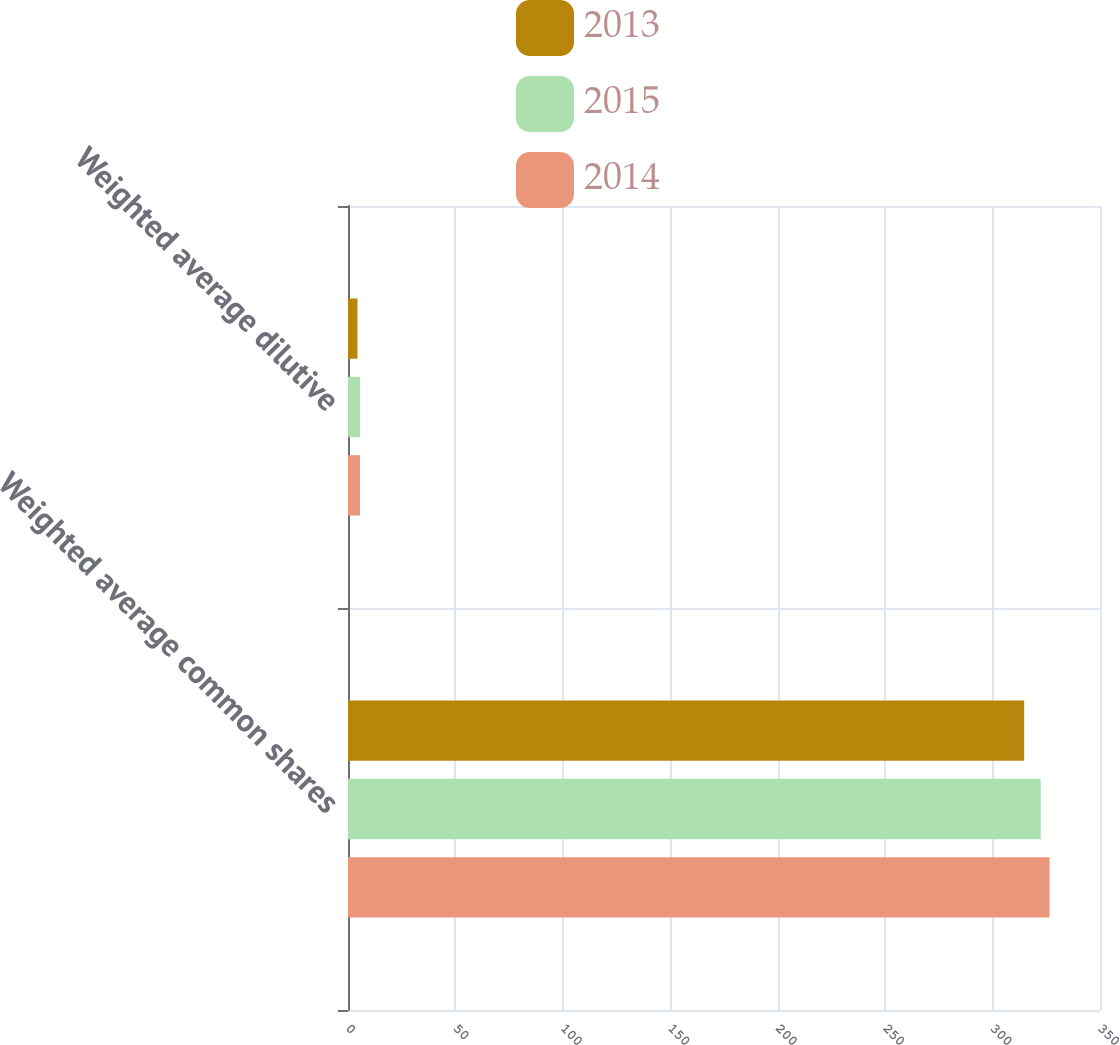Convert chart to OTSL. <chart><loc_0><loc_0><loc_500><loc_500><stacked_bar_chart><ecel><fcel>Weighted average common shares<fcel>Weighted average dilutive<nl><fcel>2013<fcel>314.7<fcel>4.4<nl><fcel>2015<fcel>322.4<fcel>5.6<nl><fcel>2014<fcel>326.5<fcel>5.6<nl></chart> 